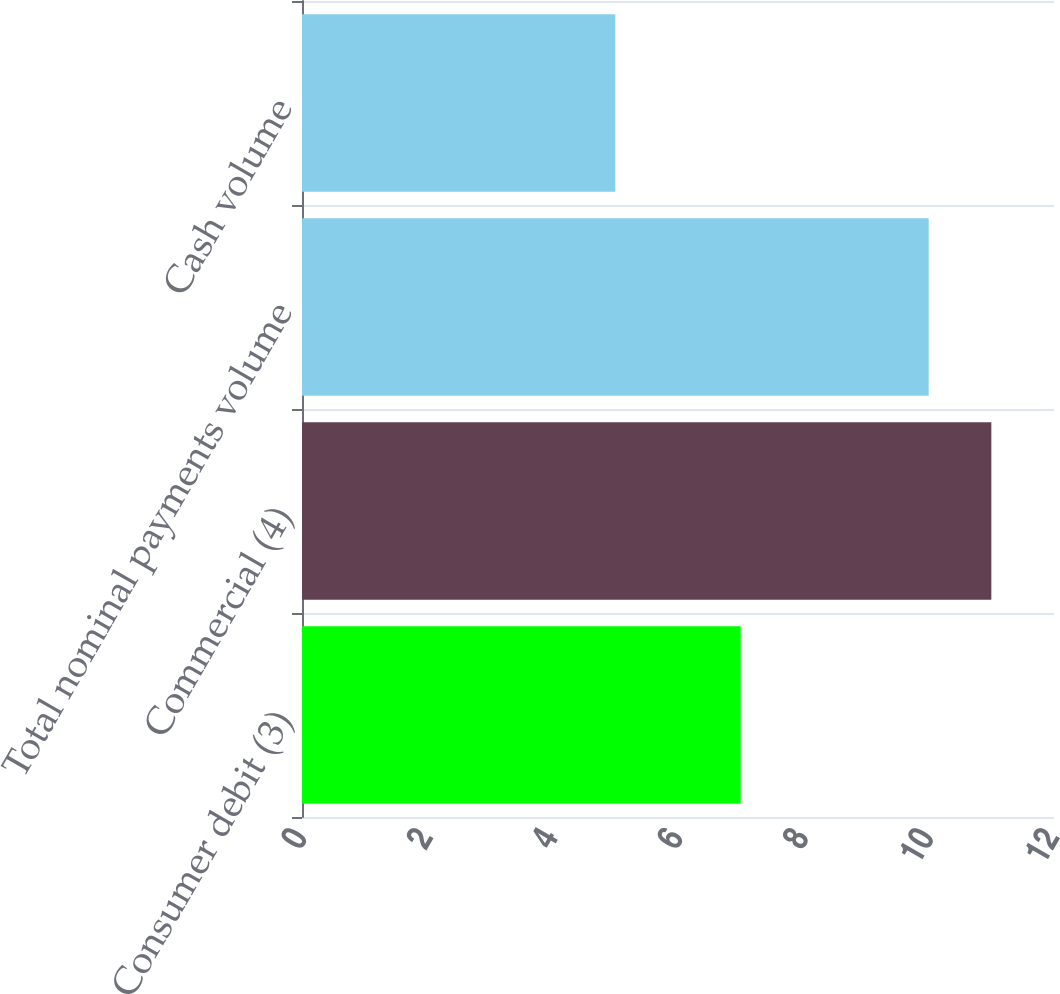<chart> <loc_0><loc_0><loc_500><loc_500><bar_chart><fcel>Consumer debit (3)<fcel>Commercial (4)<fcel>Total nominal payments volume<fcel>Cash volume<nl><fcel>7<fcel>11<fcel>10<fcel>5<nl></chart> 